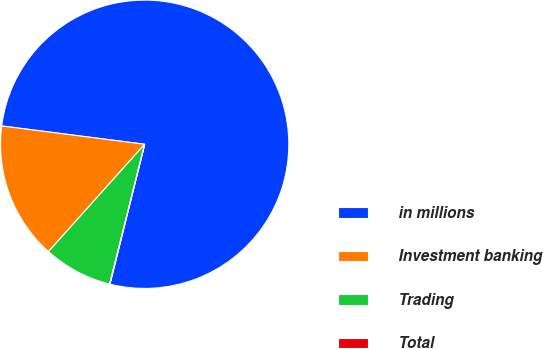Convert chart. <chart><loc_0><loc_0><loc_500><loc_500><pie_chart><fcel>in millions<fcel>Investment banking<fcel>Trading<fcel>Total<nl><fcel>76.84%<fcel>15.4%<fcel>7.72%<fcel>0.04%<nl></chart> 